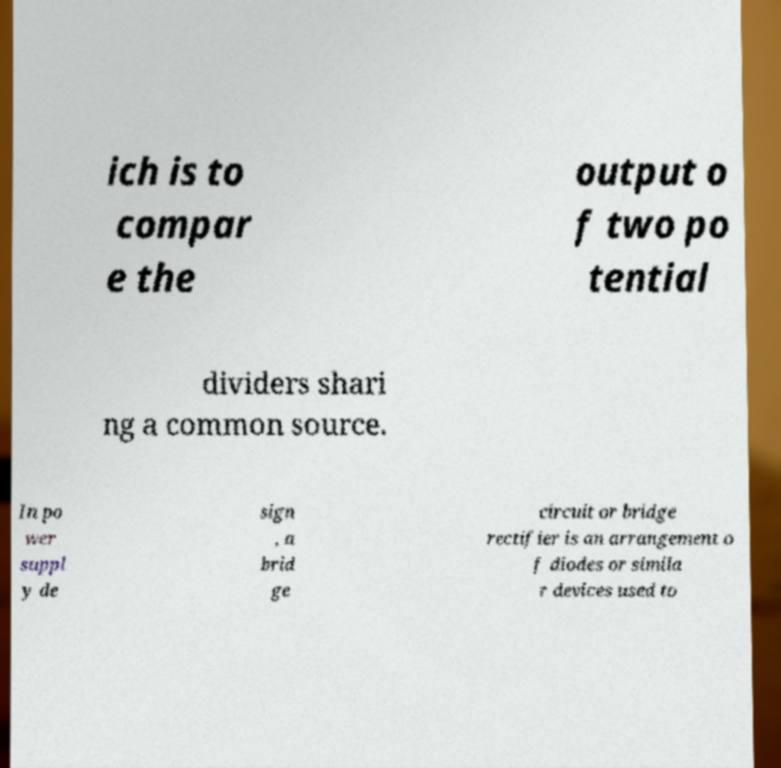What messages or text are displayed in this image? I need them in a readable, typed format. ich is to compar e the output o f two po tential dividers shari ng a common source. In po wer suppl y de sign , a brid ge circuit or bridge rectifier is an arrangement o f diodes or simila r devices used to 